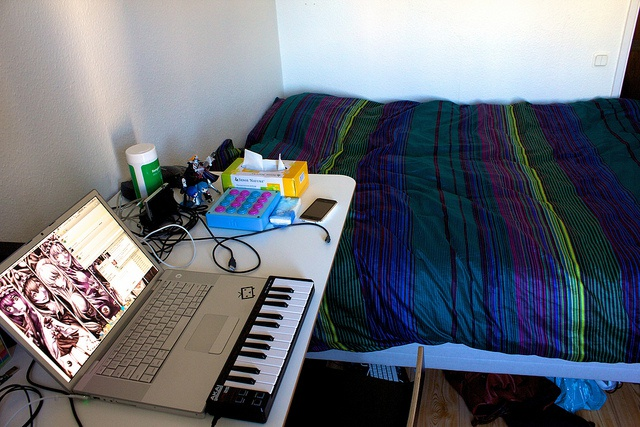Describe the objects in this image and their specific colors. I can see bed in gray, black, navy, and blue tones, laptop in gray, white, and black tones, chair in gray, black, and brown tones, and cell phone in gray, black, and lightgray tones in this image. 